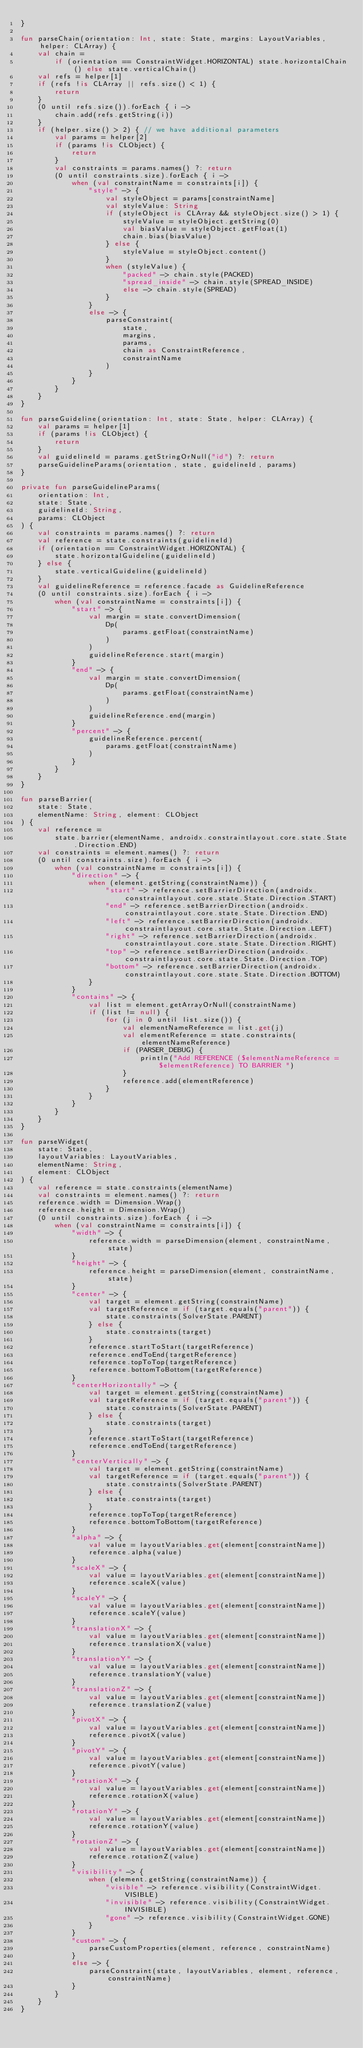<code> <loc_0><loc_0><loc_500><loc_500><_Kotlin_>}

fun parseChain(orientation: Int, state: State, margins: LayoutVariables, helper: CLArray) {
    val chain =
        if (orientation == ConstraintWidget.HORIZONTAL) state.horizontalChain() else state.verticalChain()
    val refs = helper[1]
    if (refs !is CLArray || refs.size() < 1) {
        return
    }
    (0 until refs.size()).forEach { i ->
        chain.add(refs.getString(i))
    }
    if (helper.size() > 2) { // we have additional parameters
        val params = helper[2]
        if (params !is CLObject) {
            return
        }
        val constraints = params.names() ?: return
        (0 until constraints.size).forEach { i ->
            when (val constraintName = constraints[i]) {
                "style" -> {
                    val styleObject = params[constraintName]
                    val styleValue: String
                    if (styleObject is CLArray && styleObject.size() > 1) {
                        styleValue = styleObject.getString(0)
                        val biasValue = styleObject.getFloat(1)
                        chain.bias(biasValue)
                    } else {
                        styleValue = styleObject.content()
                    }
                    when (styleValue) {
                        "packed" -> chain.style(PACKED)
                        "spread_inside" -> chain.style(SPREAD_INSIDE)
                        else -> chain.style(SPREAD)
                    }
                }
                else -> {
                    parseConstraint(
                        state,
                        margins,
                        params,
                        chain as ConstraintReference,
                        constraintName
                    )
                }
            }
        }
    }
}

fun parseGuideline(orientation: Int, state: State, helper: CLArray) {
    val params = helper[1]
    if (params !is CLObject) {
        return
    }
    val guidelineId = params.getStringOrNull("id") ?: return
    parseGuidelineParams(orientation, state, guidelineId, params)
}

private fun parseGuidelineParams(
    orientation: Int,
    state: State,
    guidelineId: String,
    params: CLObject
) {
    val constraints = params.names() ?: return
    val reference = state.constraints(guidelineId)
    if (orientation == ConstraintWidget.HORIZONTAL) {
        state.horizontalGuideline(guidelineId)
    } else {
        state.verticalGuideline(guidelineId)
    }
    val guidelineReference = reference.facade as GuidelineReference
    (0 until constraints.size).forEach { i ->
        when (val constraintName = constraints[i]) {
            "start" -> {
                val margin = state.convertDimension(
                    Dp(
                        params.getFloat(constraintName)
                    )
                )
                guidelineReference.start(margin)
            }
            "end" -> {
                val margin = state.convertDimension(
                    Dp(
                        params.getFloat(constraintName)
                    )
                )
                guidelineReference.end(margin)
            }
            "percent" -> {
                guidelineReference.percent(
                    params.getFloat(constraintName)
                )
            }
        }
    }
}

fun parseBarrier(
    state: State,
    elementName: String, element: CLObject
) {
    val reference =
        state.barrier(elementName, androidx.constraintlayout.core.state.State.Direction.END)
    val constraints = element.names() ?: return
    (0 until constraints.size).forEach { i ->
        when (val constraintName = constraints[i]) {
            "direction" -> {
                when (element.getString(constraintName)) {
                    "start" -> reference.setBarrierDirection(androidx.constraintlayout.core.state.State.Direction.START)
                    "end" -> reference.setBarrierDirection(androidx.constraintlayout.core.state.State.Direction.END)
                    "left" -> reference.setBarrierDirection(androidx.constraintlayout.core.state.State.Direction.LEFT)
                    "right" -> reference.setBarrierDirection(androidx.constraintlayout.core.state.State.Direction.RIGHT)
                    "top" -> reference.setBarrierDirection(androidx.constraintlayout.core.state.State.Direction.TOP)
                    "bottom" -> reference.setBarrierDirection(androidx.constraintlayout.core.state.State.Direction.BOTTOM)
                }
            }
            "contains" -> {
                val list = element.getArrayOrNull(constraintName)
                if (list != null) {
                    for (j in 0 until list.size()) {
                        val elementNameReference = list.get(j)
                        val elementReference = state.constraints(elementNameReference)
                        if (PARSER_DEBUG) {
                            println("Add REFERENCE ($elementNameReference = $elementReference) TO BARRIER ")
                        }
                        reference.add(elementReference)
                    }
                }
            }
        }
    }
}

fun parseWidget(
    state: State,
    layoutVariables: LayoutVariables,
    elementName: String,
    element: CLObject
) {
    val reference = state.constraints(elementName)
    val constraints = element.names() ?: return
    reference.width = Dimension.Wrap()
    reference.height = Dimension.Wrap()
    (0 until constraints.size).forEach { i ->
        when (val constraintName = constraints[i]) {
            "width" -> {
                reference.width = parseDimension(element, constraintName, state)
            }
            "height" -> {
                reference.height = parseDimension(element, constraintName, state)
            }
            "center" -> {
                val target = element.getString(constraintName)
                val targetReference = if (target.equals("parent")) {
                    state.constraints(SolverState.PARENT)
                } else {
                    state.constraints(target)
                }
                reference.startToStart(targetReference)
                reference.endToEnd(targetReference)
                reference.topToTop(targetReference)
                reference.bottomToBottom(targetReference)
            }
            "centerHorizontally" -> {
                val target = element.getString(constraintName)
                val targetReference = if (target.equals("parent")) {
                    state.constraints(SolverState.PARENT)
                } else {
                    state.constraints(target)
                }
                reference.startToStart(targetReference)
                reference.endToEnd(targetReference)
            }
            "centerVertically" -> {
                val target = element.getString(constraintName)
                val targetReference = if (target.equals("parent")) {
                    state.constraints(SolverState.PARENT)
                } else {
                    state.constraints(target)
                }
                reference.topToTop(targetReference)
                reference.bottomToBottom(targetReference)
            }
            "alpha" -> {
                val value = layoutVariables.get(element[constraintName])
                reference.alpha(value)
            }
            "scaleX" -> {
                val value = layoutVariables.get(element[constraintName])
                reference.scaleX(value)
            }
            "scaleY" -> {
                val value = layoutVariables.get(element[constraintName])
                reference.scaleY(value)
            }
            "translationX" -> {
                val value = layoutVariables.get(element[constraintName])
                reference.translationX(value)
            }
            "translationY" -> {
                val value = layoutVariables.get(element[constraintName])
                reference.translationY(value)
            }
            "translationZ" -> {
                val value = layoutVariables.get(element[constraintName])
                reference.translationZ(value)
            }
            "pivotX" -> {
                val value = layoutVariables.get(element[constraintName])
                reference.pivotX(value)
            }
            "pivotY" -> {
                val value = layoutVariables.get(element[constraintName])
                reference.pivotY(value)
            }
            "rotationX" -> {
                val value = layoutVariables.get(element[constraintName])
                reference.rotationX(value)
            }
            "rotationY" -> {
                val value = layoutVariables.get(element[constraintName])
                reference.rotationY(value)
            }
            "rotationZ" -> {
                val value = layoutVariables.get(element[constraintName])
                reference.rotationZ(value)
            }
            "visibility" -> {
                when (element.getString(constraintName)) {
                    "visible" -> reference.visibility(ConstraintWidget.VISIBLE)
                    "invisible" -> reference.visibility(ConstraintWidget.INVISIBLE)
                    "gone" -> reference.visibility(ConstraintWidget.GONE)
                }
            }
            "custom" -> {
                parseCustomProperties(element, reference, constraintName)
            }
            else -> {
                parseConstraint(state, layoutVariables, element, reference, constraintName)
            }
        }
    }
}
</code> 